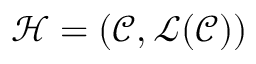Convert formula to latex. <formula><loc_0><loc_0><loc_500><loc_500>\mathcal { H } = ( \mathcal { C } , \mathcal { L } ( \mathcal { C } ) )</formula> 